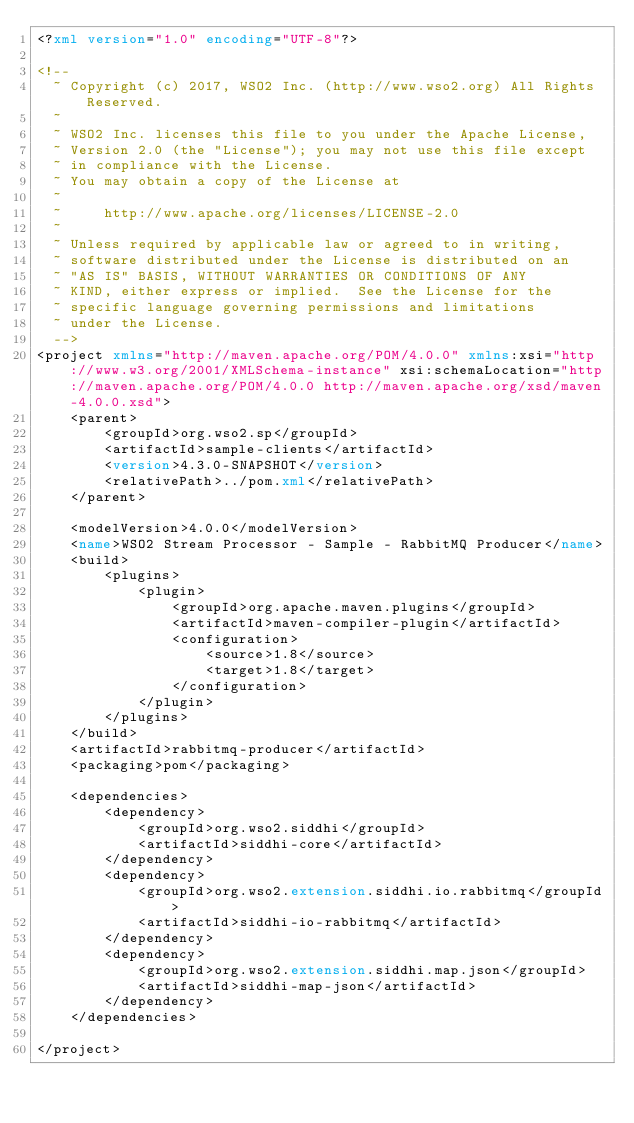<code> <loc_0><loc_0><loc_500><loc_500><_XML_><?xml version="1.0" encoding="UTF-8"?>

<!--
  ~ Copyright (c) 2017, WSO2 Inc. (http://www.wso2.org) All Rights Reserved.
  ~
  ~ WSO2 Inc. licenses this file to you under the Apache License,
  ~ Version 2.0 (the "License"); you may not use this file except
  ~ in compliance with the License.
  ~ You may obtain a copy of the License at
  ~
  ~     http://www.apache.org/licenses/LICENSE-2.0
  ~
  ~ Unless required by applicable law or agreed to in writing,
  ~ software distributed under the License is distributed on an
  ~ "AS IS" BASIS, WITHOUT WARRANTIES OR CONDITIONS OF ANY
  ~ KIND, either express or implied.  See the License for the
  ~ specific language governing permissions and limitations
  ~ under the License.
  -->
<project xmlns="http://maven.apache.org/POM/4.0.0" xmlns:xsi="http://www.w3.org/2001/XMLSchema-instance" xsi:schemaLocation="http://maven.apache.org/POM/4.0.0 http://maven.apache.org/xsd/maven-4.0.0.xsd">
    <parent>
        <groupId>org.wso2.sp</groupId>
        <artifactId>sample-clients</artifactId>
        <version>4.3.0-SNAPSHOT</version>
        <relativePath>../pom.xml</relativePath>
    </parent>

    <modelVersion>4.0.0</modelVersion>
    <name>WSO2 Stream Processor - Sample - RabbitMQ Producer</name>
    <build>
        <plugins>
            <plugin>
                <groupId>org.apache.maven.plugins</groupId>
                <artifactId>maven-compiler-plugin</artifactId>
                <configuration>
                    <source>1.8</source>
                    <target>1.8</target>
                </configuration>
            </plugin>
        </plugins>
    </build>
    <artifactId>rabbitmq-producer</artifactId>
    <packaging>pom</packaging>

    <dependencies>
        <dependency>
            <groupId>org.wso2.siddhi</groupId>
            <artifactId>siddhi-core</artifactId>
        </dependency>
        <dependency>
            <groupId>org.wso2.extension.siddhi.io.rabbitmq</groupId>
            <artifactId>siddhi-io-rabbitmq</artifactId>
        </dependency>
        <dependency>
            <groupId>org.wso2.extension.siddhi.map.json</groupId>
            <artifactId>siddhi-map-json</artifactId>
        </dependency>
    </dependencies>

</project>
</code> 